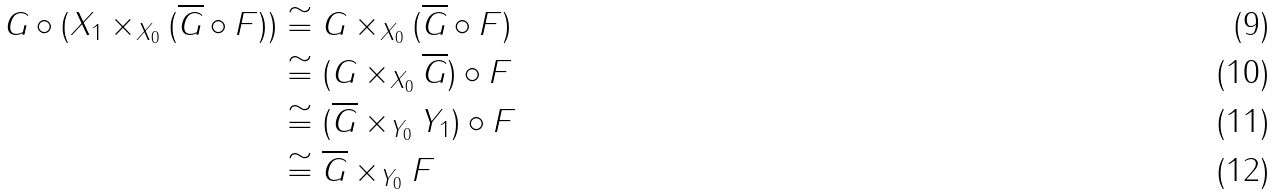Convert formula to latex. <formula><loc_0><loc_0><loc_500><loc_500>G \circ ( X _ { 1 } \times _ { X _ { 0 } } ( \overline { G } \circ F ) ) & \cong G \times _ { X _ { 0 } } ( \overline { G } \circ F ) \\ & \cong ( G \times _ { X _ { 0 } } \overline { G } ) \circ F \\ & \cong ( \overline { G } \times _ { Y _ { 0 } } Y _ { 1 } ) \circ F \\ & \cong \overline { G } \times _ { Y _ { 0 } } F</formula> 